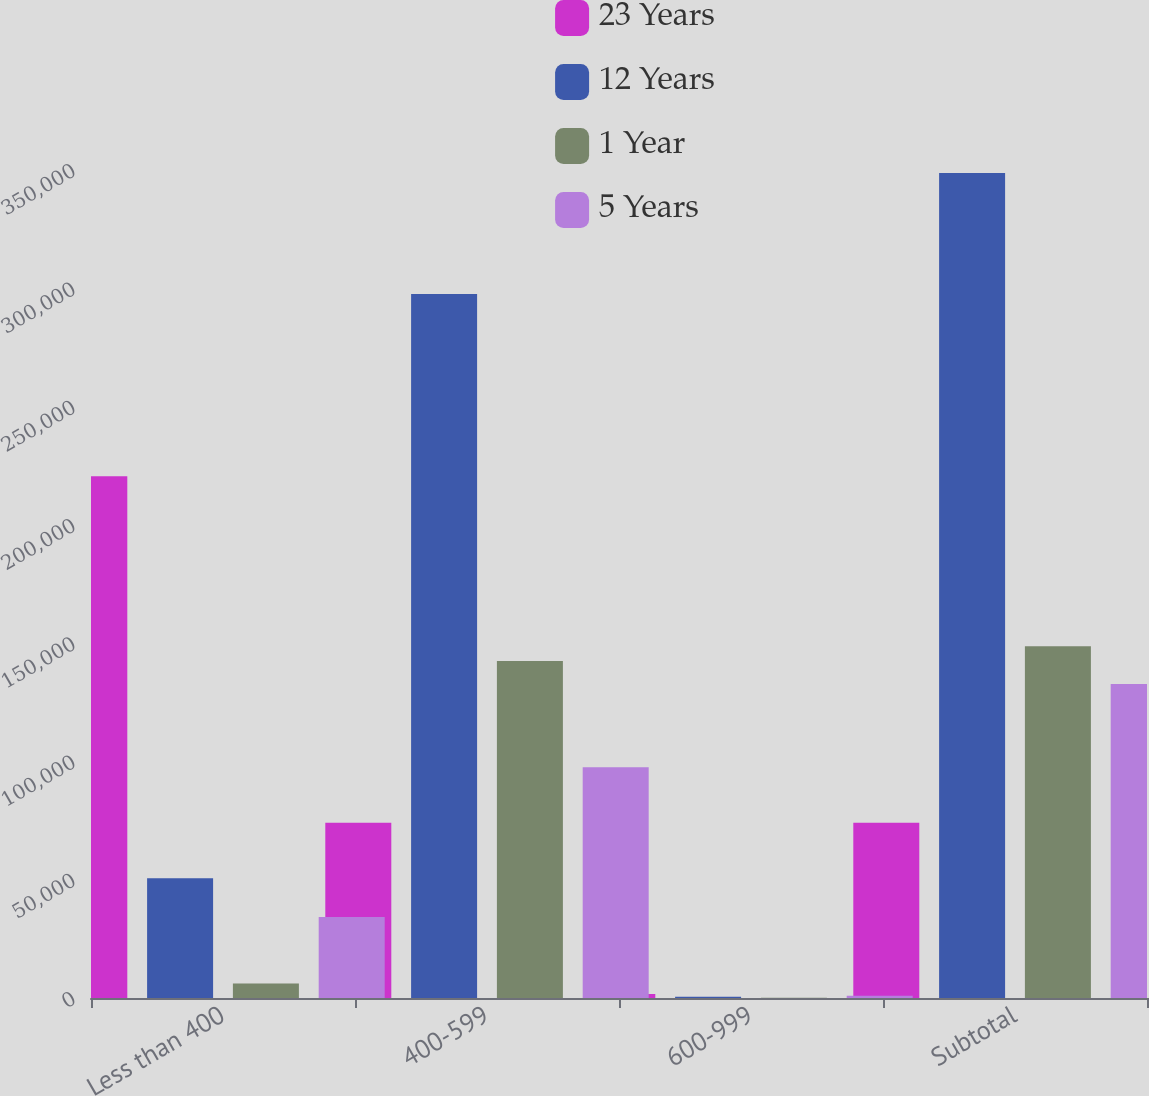Convert chart to OTSL. <chart><loc_0><loc_0><loc_500><loc_500><stacked_bar_chart><ecel><fcel>Less than 400<fcel>400-599<fcel>600-999<fcel>Subtotal<nl><fcel>23 Years<fcel>220591<fcel>74099<fcel>1716<fcel>74099<nl><fcel>12 Years<fcel>50622<fcel>297594<fcel>544<fcel>348760<nl><fcel>1 Year<fcel>6084<fcel>142402<fcel>158<fcel>148644<nl><fcel>5 Years<fcel>34275<fcel>97576<fcel>920<fcel>132771<nl></chart> 